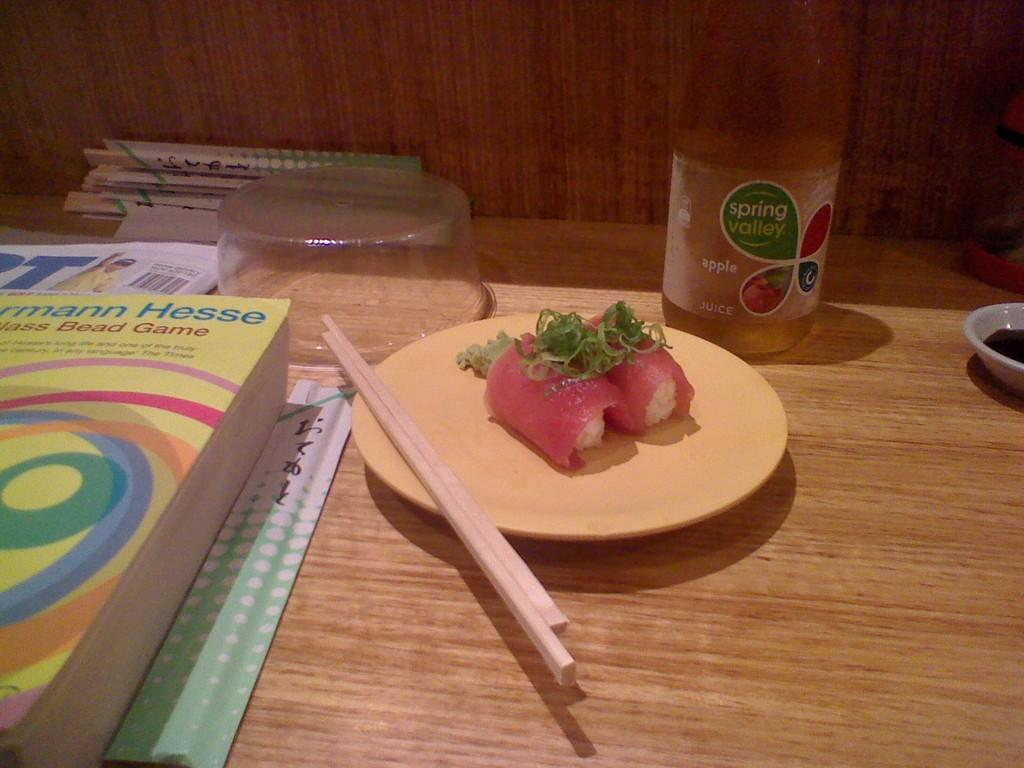<image>
Describe the image concisely. a plate with sushi next to a bottle of Spring Valley Apple Juice 